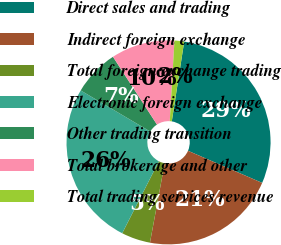<chart> <loc_0><loc_0><loc_500><loc_500><pie_chart><fcel>Direct sales and trading<fcel>Indirect foreign exchange<fcel>Total foreign exchange trading<fcel>Electronic foreign exchange<fcel>Other trading transition<fcel>Total brokerage and other<fcel>Total trading services revenue<nl><fcel>29.05%<fcel>21.41%<fcel>4.59%<fcel>25.99%<fcel>7.34%<fcel>10.09%<fcel>1.53%<nl></chart> 